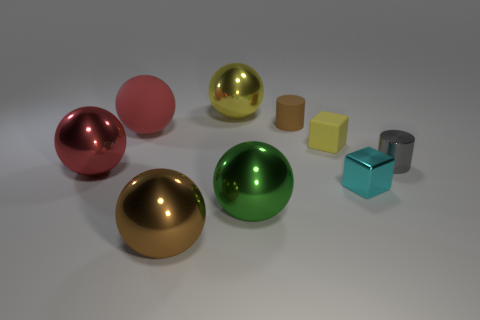How many big red balls have the same material as the small brown cylinder?
Your response must be concise. 1. There is a ball that is right of the big yellow ball; does it have the same color as the metallic cylinder?
Provide a short and direct response. No. What number of blue objects are large shiny things or large rubber balls?
Your response must be concise. 0. Are there any other things that have the same material as the green ball?
Your answer should be compact. Yes. Is the material of the red object that is behind the small yellow object the same as the brown cylinder?
Make the answer very short. Yes. What number of things are either green metallic balls or rubber objects that are on the left side of the large yellow metallic sphere?
Provide a succinct answer. 2. There is a metal object to the left of the big thing that is in front of the green sphere; how many green shiny balls are behind it?
Provide a short and direct response. 0. Does the brown object behind the tiny cyan thing have the same shape as the large brown object?
Give a very brief answer. No. Are there any big spheres in front of the cylinder behind the rubber cube?
Your answer should be very brief. Yes. What number of tiny purple shiny blocks are there?
Keep it short and to the point. 0. 